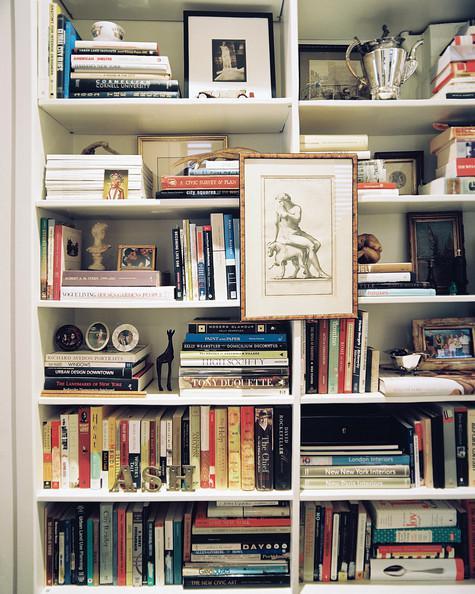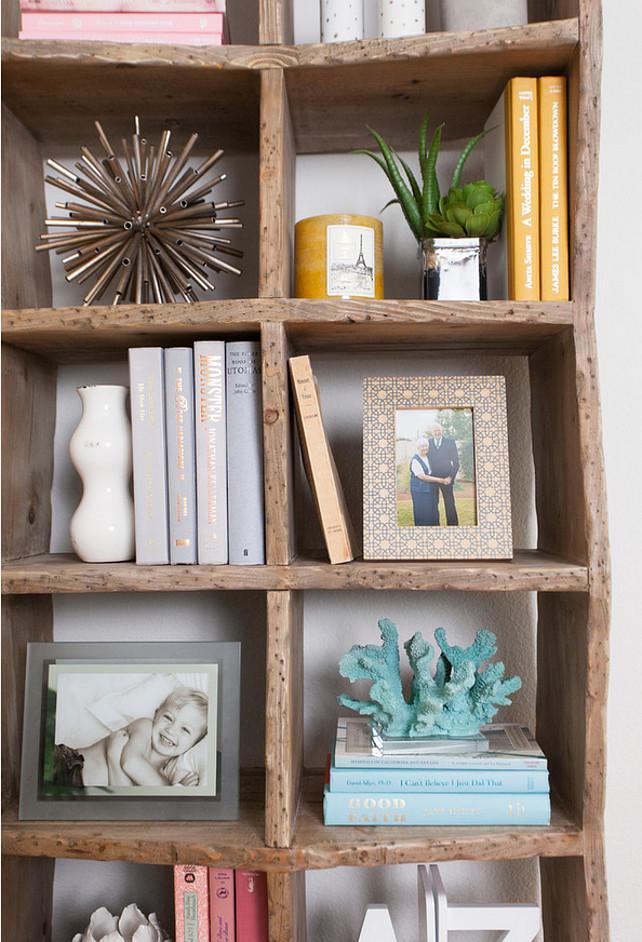The first image is the image on the left, the second image is the image on the right. Given the left and right images, does the statement "One image is a room with a chandelier and a white bookcase that fills a wall." hold true? Answer yes or no. No. The first image is the image on the left, the second image is the image on the right. Evaluate the accuracy of this statement regarding the images: "In one image, artwork is hung on the center front of a white built-in shelving unit.". Is it true? Answer yes or no. Yes. 